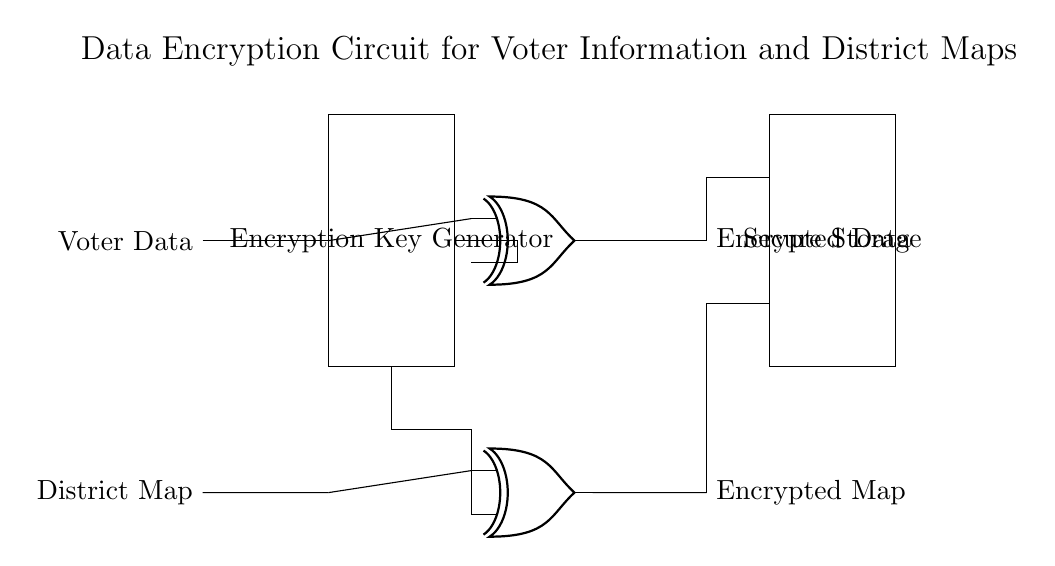What is the main purpose of the circuit? The circuit is designed to encrypt sensitive voter information and district maps, ensuring data protection.
Answer: Encrypt voter data and district maps How many XOR gates are used in the circuit? There are two XOR gates present in the diagram, one for voter data and another for the district map.
Answer: Two What components represent the encrypted outputs? The encrypted outputs are represented by the nodes labeled "Encrypted Data" and "Encrypted Map", which indicate the outputs from the XOR gates.
Answer: Encrypted Data and Encrypted Map What is the role of the "Encryption Key Generator"? The "Encryption Key Generator" provides the necessary key to the XOR gates for the encryption process, allowing the data to be securely modified.
Answer: Generate encryption key Where does the "Secure Storage" component connect in the circuit? The "Secure Storage" component connects to both XOR gate outputs to store the encrypted data and map securely.
Answer: To both encrypted outputs Why is it important to encrypt voter data and district maps? Encrypting this sensitive information is crucial to protect it from unauthorized access and ensure the integrity of electoral processes.
Answer: To protect sensitive information 